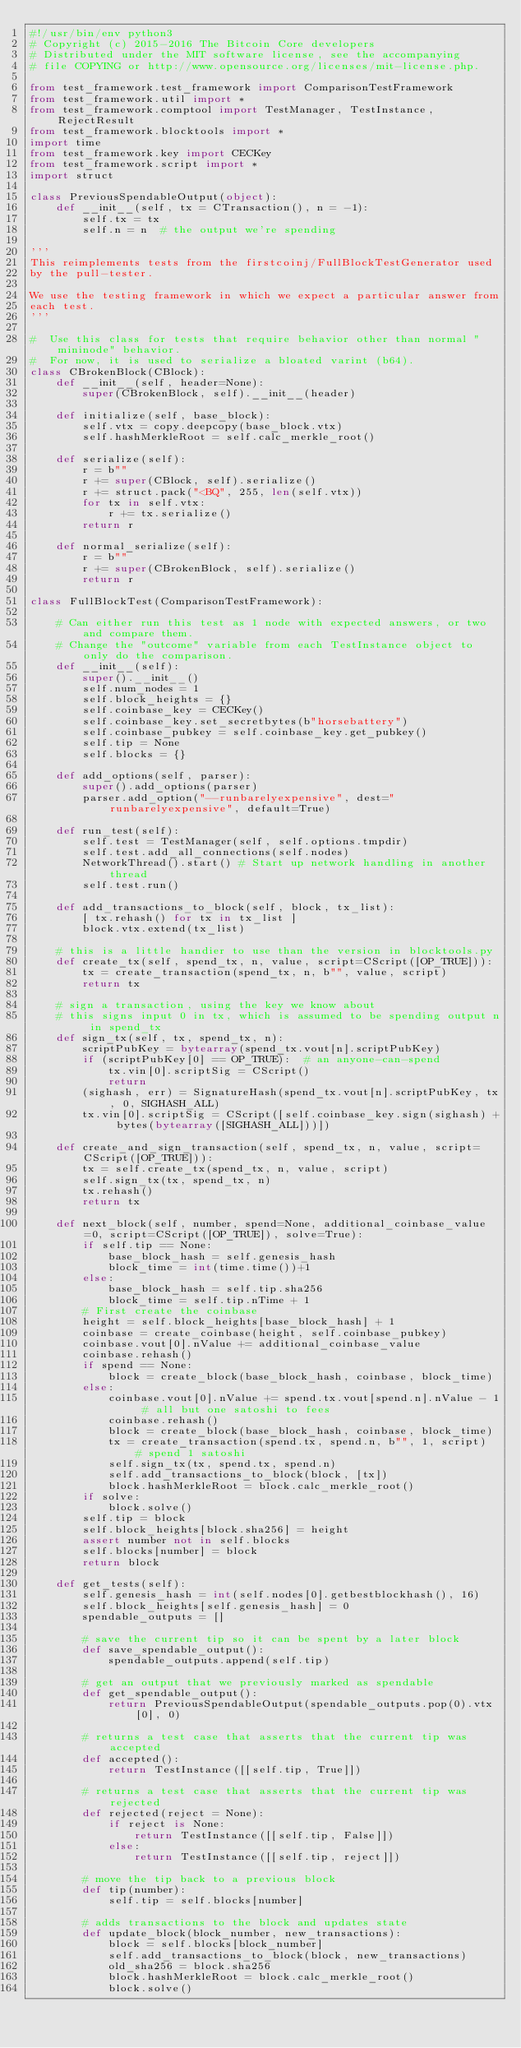Convert code to text. <code><loc_0><loc_0><loc_500><loc_500><_Python_>#!/usr/bin/env python3
# Copyright (c) 2015-2016 The Bitcoin Core developers
# Distributed under the MIT software license, see the accompanying
# file COPYING or http://www.opensource.org/licenses/mit-license.php.

from test_framework.test_framework import ComparisonTestFramework
from test_framework.util import *
from test_framework.comptool import TestManager, TestInstance, RejectResult
from test_framework.blocktools import *
import time
from test_framework.key import CECKey
from test_framework.script import *
import struct

class PreviousSpendableOutput(object):
    def __init__(self, tx = CTransaction(), n = -1):
        self.tx = tx
        self.n = n  # the output we're spending

'''
This reimplements tests from the firstcoinj/FullBlockTestGenerator used
by the pull-tester.

We use the testing framework in which we expect a particular answer from
each test.
'''

#  Use this class for tests that require behavior other than normal "mininode" behavior.
#  For now, it is used to serialize a bloated varint (b64).
class CBrokenBlock(CBlock):
    def __init__(self, header=None):
        super(CBrokenBlock, self).__init__(header)

    def initialize(self, base_block):
        self.vtx = copy.deepcopy(base_block.vtx)
        self.hashMerkleRoot = self.calc_merkle_root()

    def serialize(self):
        r = b""
        r += super(CBlock, self).serialize()
        r += struct.pack("<BQ", 255, len(self.vtx))
        for tx in self.vtx:
            r += tx.serialize()
        return r

    def normal_serialize(self):
        r = b""
        r += super(CBrokenBlock, self).serialize()
        return r

class FullBlockTest(ComparisonTestFramework):

    # Can either run this test as 1 node with expected answers, or two and compare them.
    # Change the "outcome" variable from each TestInstance object to only do the comparison.
    def __init__(self):
        super().__init__()
        self.num_nodes = 1
        self.block_heights = {}
        self.coinbase_key = CECKey()
        self.coinbase_key.set_secretbytes(b"horsebattery")
        self.coinbase_pubkey = self.coinbase_key.get_pubkey()
        self.tip = None
        self.blocks = {}

    def add_options(self, parser):
        super().add_options(parser)
        parser.add_option("--runbarelyexpensive", dest="runbarelyexpensive", default=True)

    def run_test(self):
        self.test = TestManager(self, self.options.tmpdir)
        self.test.add_all_connections(self.nodes)
        NetworkThread().start() # Start up network handling in another thread
        self.test.run()

    def add_transactions_to_block(self, block, tx_list):
        [ tx.rehash() for tx in tx_list ]
        block.vtx.extend(tx_list)

    # this is a little handier to use than the version in blocktools.py
    def create_tx(self, spend_tx, n, value, script=CScript([OP_TRUE])):
        tx = create_transaction(spend_tx, n, b"", value, script)
        return tx

    # sign a transaction, using the key we know about
    # this signs input 0 in tx, which is assumed to be spending output n in spend_tx
    def sign_tx(self, tx, spend_tx, n):
        scriptPubKey = bytearray(spend_tx.vout[n].scriptPubKey)
        if (scriptPubKey[0] == OP_TRUE):  # an anyone-can-spend
            tx.vin[0].scriptSig = CScript()
            return
        (sighash, err) = SignatureHash(spend_tx.vout[n].scriptPubKey, tx, 0, SIGHASH_ALL)
        tx.vin[0].scriptSig = CScript([self.coinbase_key.sign(sighash) + bytes(bytearray([SIGHASH_ALL]))])

    def create_and_sign_transaction(self, spend_tx, n, value, script=CScript([OP_TRUE])):
        tx = self.create_tx(spend_tx, n, value, script)
        self.sign_tx(tx, spend_tx, n)
        tx.rehash()
        return tx

    def next_block(self, number, spend=None, additional_coinbase_value=0, script=CScript([OP_TRUE]), solve=True):
        if self.tip == None:
            base_block_hash = self.genesis_hash
            block_time = int(time.time())+1
        else:
            base_block_hash = self.tip.sha256
            block_time = self.tip.nTime + 1
        # First create the coinbase
        height = self.block_heights[base_block_hash] + 1
        coinbase = create_coinbase(height, self.coinbase_pubkey)
        coinbase.vout[0].nValue += additional_coinbase_value
        coinbase.rehash()
        if spend == None:
            block = create_block(base_block_hash, coinbase, block_time)
        else:
            coinbase.vout[0].nValue += spend.tx.vout[spend.n].nValue - 1 # all but one satoshi to fees
            coinbase.rehash()
            block = create_block(base_block_hash, coinbase, block_time)
            tx = create_transaction(spend.tx, spend.n, b"", 1, script)  # spend 1 satoshi
            self.sign_tx(tx, spend.tx, spend.n)
            self.add_transactions_to_block(block, [tx])
            block.hashMerkleRoot = block.calc_merkle_root()
        if solve:
            block.solve()
        self.tip = block
        self.block_heights[block.sha256] = height
        assert number not in self.blocks
        self.blocks[number] = block
        return block

    def get_tests(self):
        self.genesis_hash = int(self.nodes[0].getbestblockhash(), 16)
        self.block_heights[self.genesis_hash] = 0
        spendable_outputs = []

        # save the current tip so it can be spent by a later block
        def save_spendable_output():
            spendable_outputs.append(self.tip)

        # get an output that we previously marked as spendable
        def get_spendable_output():
            return PreviousSpendableOutput(spendable_outputs.pop(0).vtx[0], 0)

        # returns a test case that asserts that the current tip was accepted
        def accepted():
            return TestInstance([[self.tip, True]])

        # returns a test case that asserts that the current tip was rejected
        def rejected(reject = None):
            if reject is None:
                return TestInstance([[self.tip, False]])
            else:
                return TestInstance([[self.tip, reject]])

        # move the tip back to a previous block
        def tip(number):
            self.tip = self.blocks[number]

        # adds transactions to the block and updates state
        def update_block(block_number, new_transactions):
            block = self.blocks[block_number]
            self.add_transactions_to_block(block, new_transactions)
            old_sha256 = block.sha256
            block.hashMerkleRoot = block.calc_merkle_root()
            block.solve()</code> 